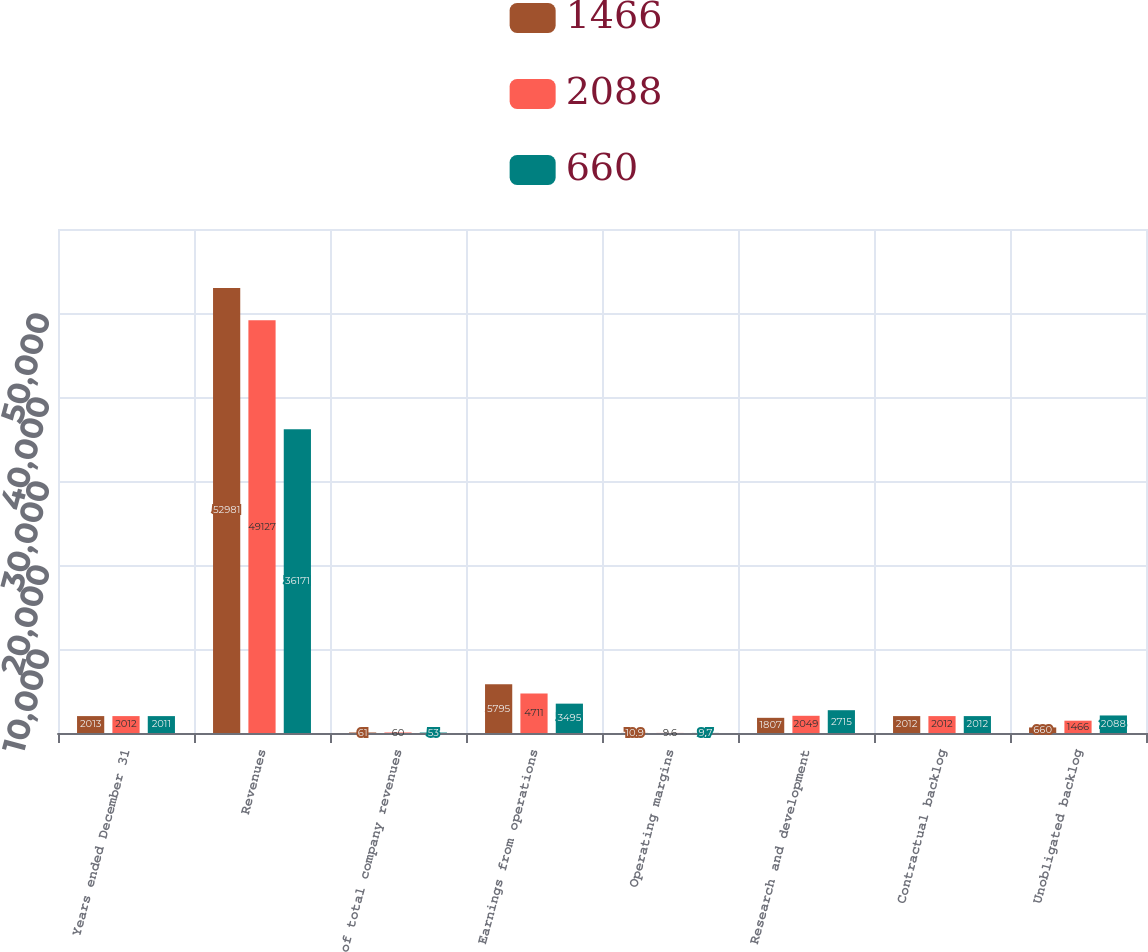<chart> <loc_0><loc_0><loc_500><loc_500><stacked_bar_chart><ecel><fcel>Years ended December 31<fcel>Revenues<fcel>of total company revenues<fcel>Earnings from operations<fcel>Operating margins<fcel>Research and development<fcel>Contractual backlog<fcel>Unobligated backlog<nl><fcel>1466<fcel>2013<fcel>52981<fcel>61<fcel>5795<fcel>10.9<fcel>1807<fcel>2012<fcel>660<nl><fcel>2088<fcel>2012<fcel>49127<fcel>60<fcel>4711<fcel>9.6<fcel>2049<fcel>2012<fcel>1466<nl><fcel>660<fcel>2011<fcel>36171<fcel>53<fcel>3495<fcel>9.7<fcel>2715<fcel>2012<fcel>2088<nl></chart> 